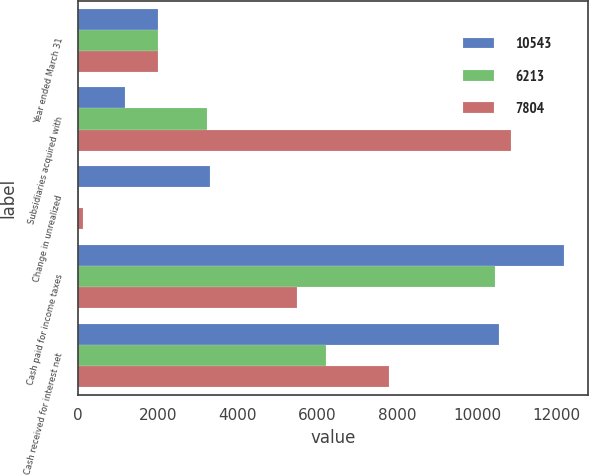<chart> <loc_0><loc_0><loc_500><loc_500><stacked_bar_chart><ecel><fcel>Year ended March 31<fcel>Subsidiaries acquired with<fcel>Change in unrealized<fcel>Cash paid for income taxes<fcel>Cash received for interest net<nl><fcel>10543<fcel>2005<fcel>1191<fcel>3317<fcel>12178<fcel>10543<nl><fcel>6213<fcel>2004<fcel>3246<fcel>37<fcel>10463<fcel>6213<nl><fcel>7804<fcel>2003<fcel>10861<fcel>134<fcel>5491<fcel>7804<nl></chart> 